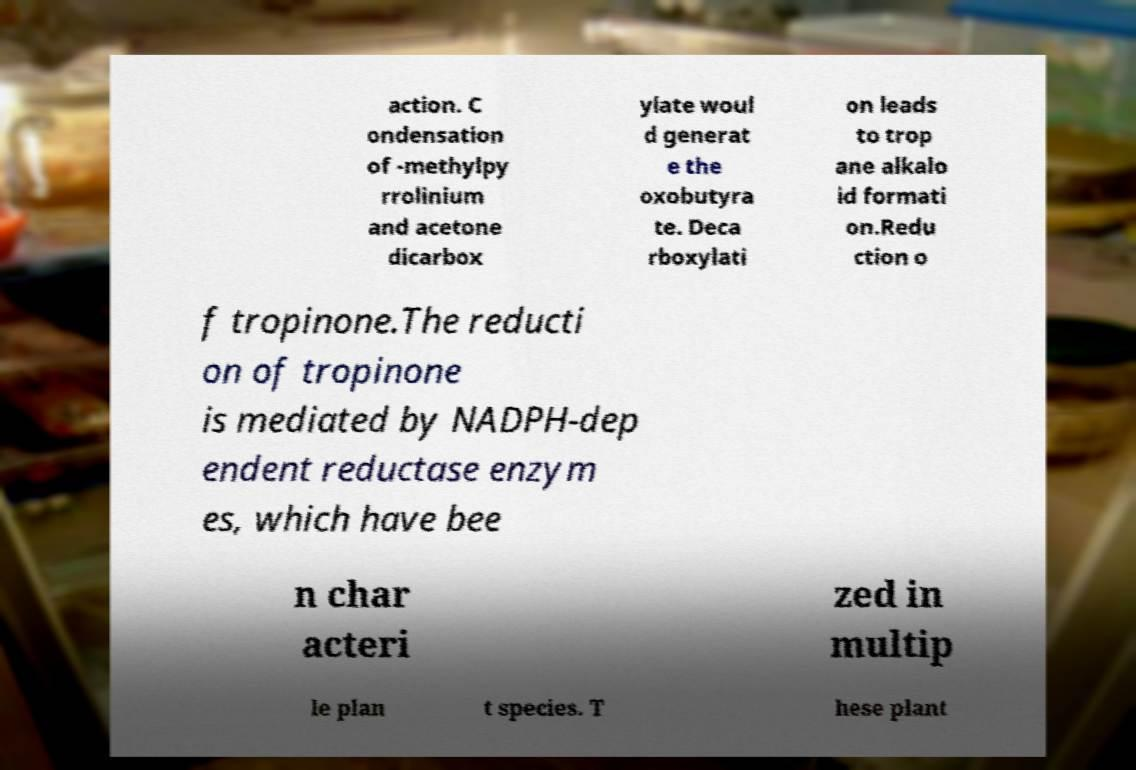Please read and relay the text visible in this image. What does it say? action. C ondensation of -methylpy rrolinium and acetone dicarbox ylate woul d generat e the oxobutyra te. Deca rboxylati on leads to trop ane alkalo id formati on.Redu ction o f tropinone.The reducti on of tropinone is mediated by NADPH-dep endent reductase enzym es, which have bee n char acteri zed in multip le plan t species. T hese plant 